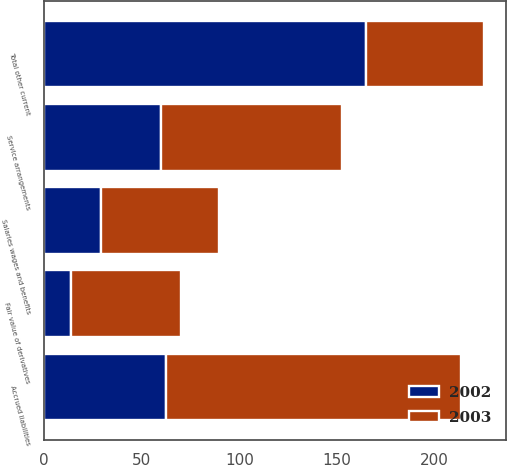<chart> <loc_0><loc_0><loc_500><loc_500><stacked_bar_chart><ecel><fcel>Service arrangements<fcel>Salaries wages and benefits<fcel>Fair value of derivatives<fcel>Accrued liabilities<fcel>Total other current<nl><fcel>2003<fcel>92.9<fcel>60.5<fcel>56.4<fcel>151.3<fcel>60.5<nl><fcel>2002<fcel>59.6<fcel>29<fcel>13.9<fcel>62.3<fcel>164.8<nl></chart> 